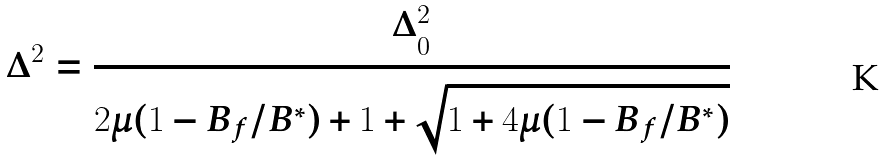Convert formula to latex. <formula><loc_0><loc_0><loc_500><loc_500>\Delta ^ { 2 } = \frac { \Delta _ { 0 } ^ { 2 } } { 2 \mu ( 1 - B _ { f } / B ^ { \ast } ) + 1 + \sqrt { 1 + 4 \mu ( 1 - B _ { f } / B ^ { \ast } ) } }</formula> 